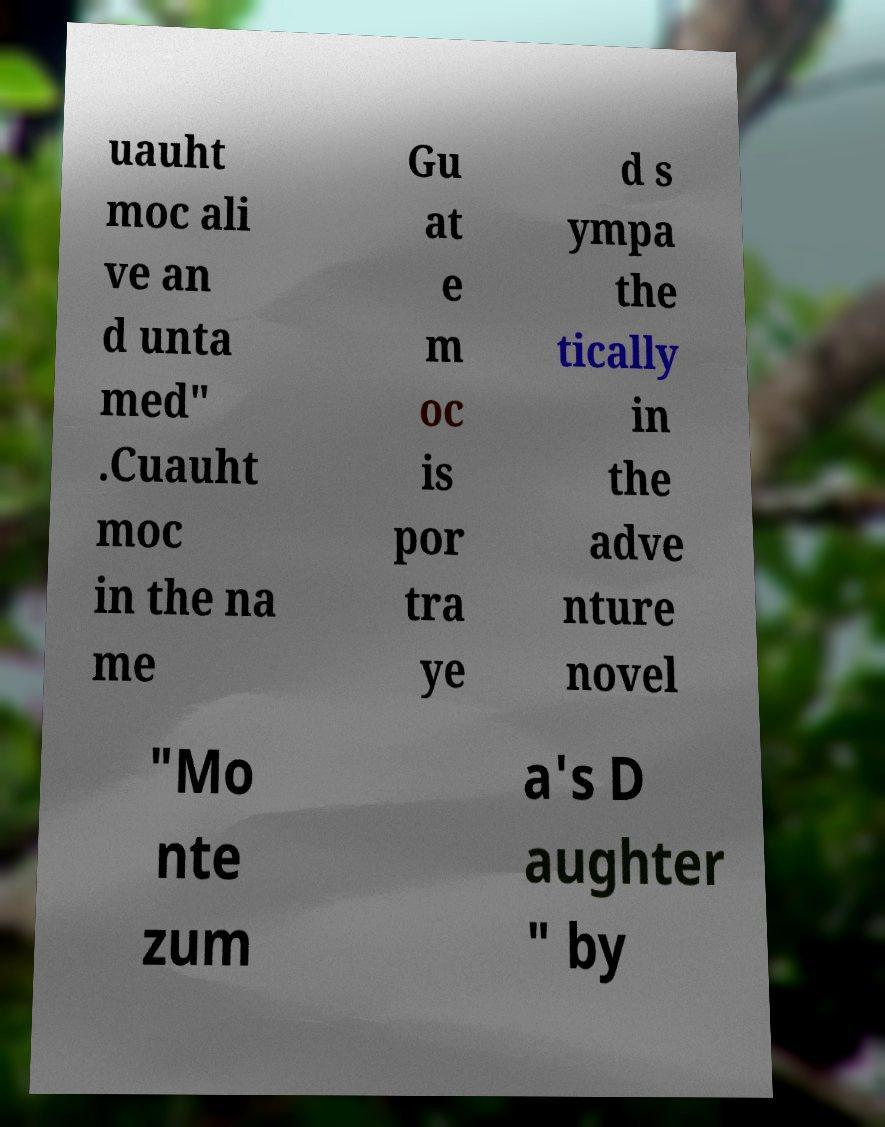Please identify and transcribe the text found in this image. uauht moc ali ve an d unta med" .Cuauht moc in the na me Gu at e m oc is por tra ye d s ympa the tically in the adve nture novel "Mo nte zum a's D aughter " by 